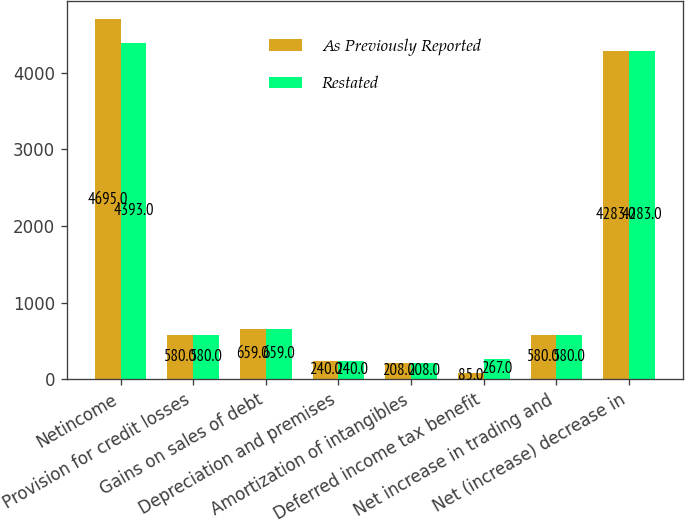<chart> <loc_0><loc_0><loc_500><loc_500><stacked_bar_chart><ecel><fcel>Netincome<fcel>Provision for credit losses<fcel>Gains on sales of debt<fcel>Depreciation and premises<fcel>Amortization of intangibles<fcel>Deferred income tax benefit<fcel>Net increase in trading and<fcel>Net (increase) decrease in<nl><fcel>As Previously Reported<fcel>4695<fcel>580<fcel>659<fcel>240<fcel>208<fcel>85<fcel>580<fcel>4283<nl><fcel>Restated<fcel>4393<fcel>580<fcel>659<fcel>240<fcel>208<fcel>267<fcel>580<fcel>4283<nl></chart> 